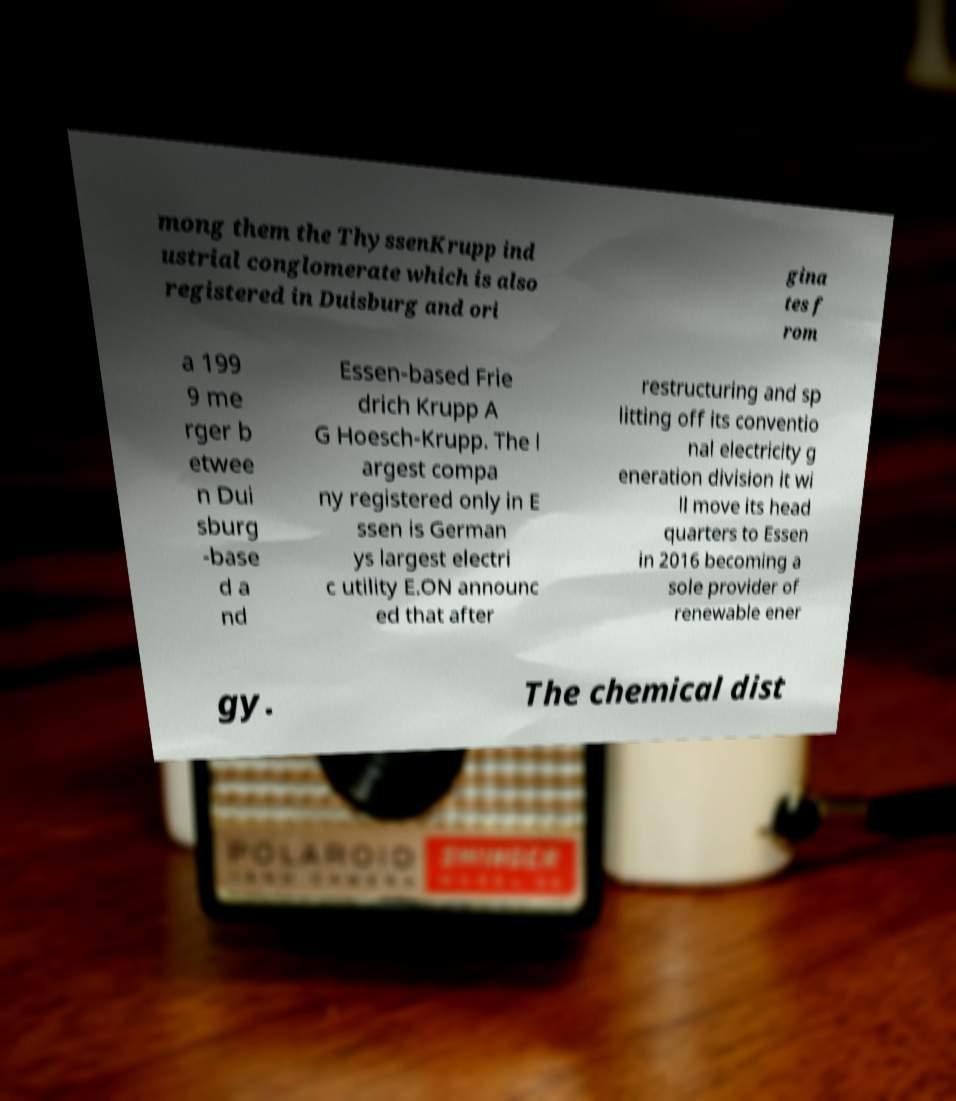I need the written content from this picture converted into text. Can you do that? mong them the ThyssenKrupp ind ustrial conglomerate which is also registered in Duisburg and ori gina tes f rom a 199 9 me rger b etwee n Dui sburg -base d a nd Essen-based Frie drich Krupp A G Hoesch-Krupp. The l argest compa ny registered only in E ssen is German ys largest electri c utility E.ON announc ed that after restructuring and sp litting off its conventio nal electricity g eneration division it wi ll move its head quarters to Essen in 2016 becoming a sole provider of renewable ener gy. The chemical dist 